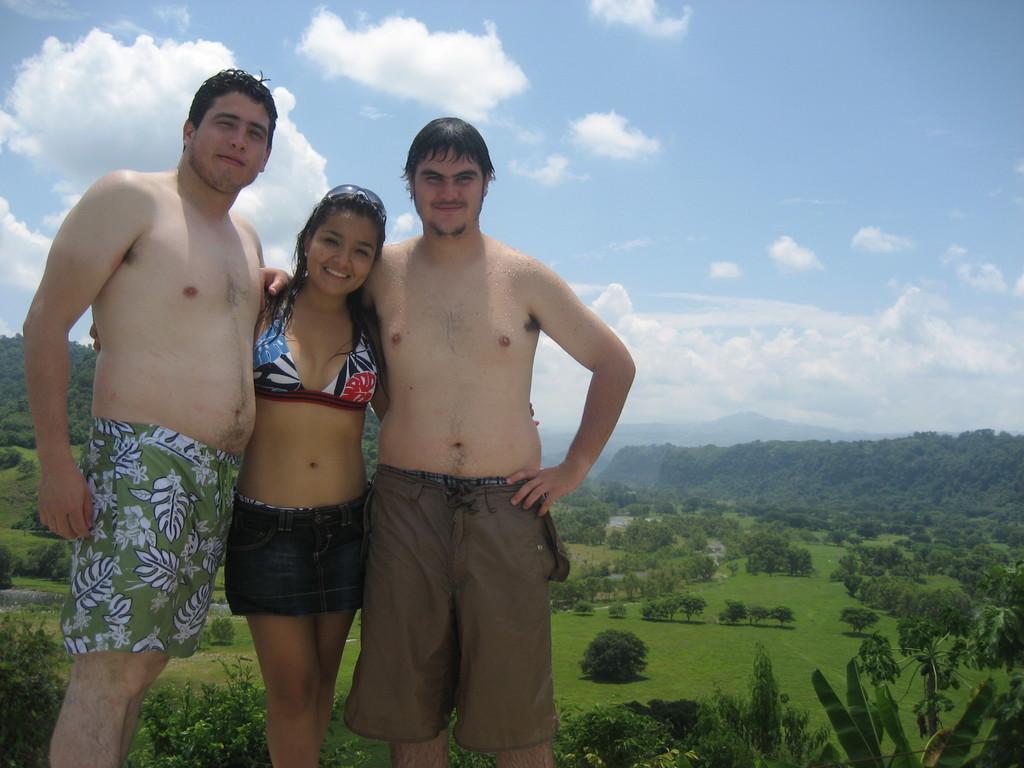How would you summarize this image in a sentence or two? In this image there is a lady and two men standing, in the background there are trees, mountain and the sky. 